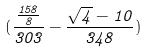<formula> <loc_0><loc_0><loc_500><loc_500>( \frac { \frac { 1 5 8 } { 8 } } { 3 0 3 } - \frac { \sqrt { 4 } - 1 0 } { 3 4 8 } )</formula> 